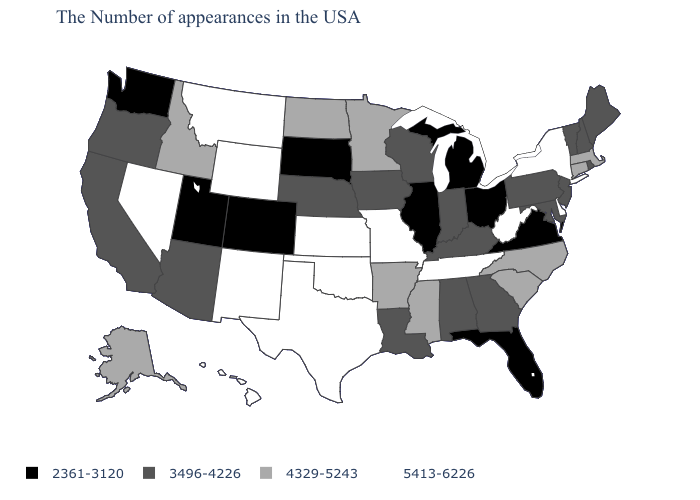What is the value of Indiana?
Give a very brief answer. 3496-4226. Name the states that have a value in the range 5413-6226?
Quick response, please. New York, Delaware, West Virginia, Tennessee, Missouri, Kansas, Oklahoma, Texas, Wyoming, New Mexico, Montana, Nevada, Hawaii. What is the value of West Virginia?
Concise answer only. 5413-6226. What is the value of Idaho?
Be succinct. 4329-5243. Does New Mexico have the highest value in the USA?
Answer briefly. Yes. What is the value of Nevada?
Short answer required. 5413-6226. What is the value of Indiana?
Give a very brief answer. 3496-4226. Name the states that have a value in the range 2361-3120?
Short answer required. Virginia, Ohio, Florida, Michigan, Illinois, South Dakota, Colorado, Utah, Washington. What is the value of Texas?
Be succinct. 5413-6226. Does the map have missing data?
Write a very short answer. No. What is the value of Nebraska?
Be succinct. 3496-4226. What is the value of Maine?
Short answer required. 3496-4226. What is the value of Oregon?
Be succinct. 3496-4226. Is the legend a continuous bar?
Be succinct. No. Which states have the highest value in the USA?
Give a very brief answer. New York, Delaware, West Virginia, Tennessee, Missouri, Kansas, Oklahoma, Texas, Wyoming, New Mexico, Montana, Nevada, Hawaii. 